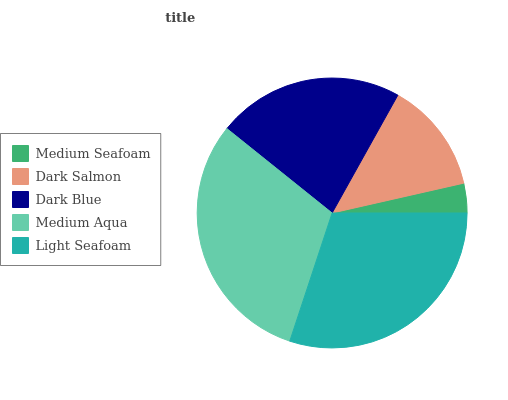Is Medium Seafoam the minimum?
Answer yes or no. Yes. Is Medium Aqua the maximum?
Answer yes or no. Yes. Is Dark Salmon the minimum?
Answer yes or no. No. Is Dark Salmon the maximum?
Answer yes or no. No. Is Dark Salmon greater than Medium Seafoam?
Answer yes or no. Yes. Is Medium Seafoam less than Dark Salmon?
Answer yes or no. Yes. Is Medium Seafoam greater than Dark Salmon?
Answer yes or no. No. Is Dark Salmon less than Medium Seafoam?
Answer yes or no. No. Is Dark Blue the high median?
Answer yes or no. Yes. Is Dark Blue the low median?
Answer yes or no. Yes. Is Medium Seafoam the high median?
Answer yes or no. No. Is Dark Salmon the low median?
Answer yes or no. No. 